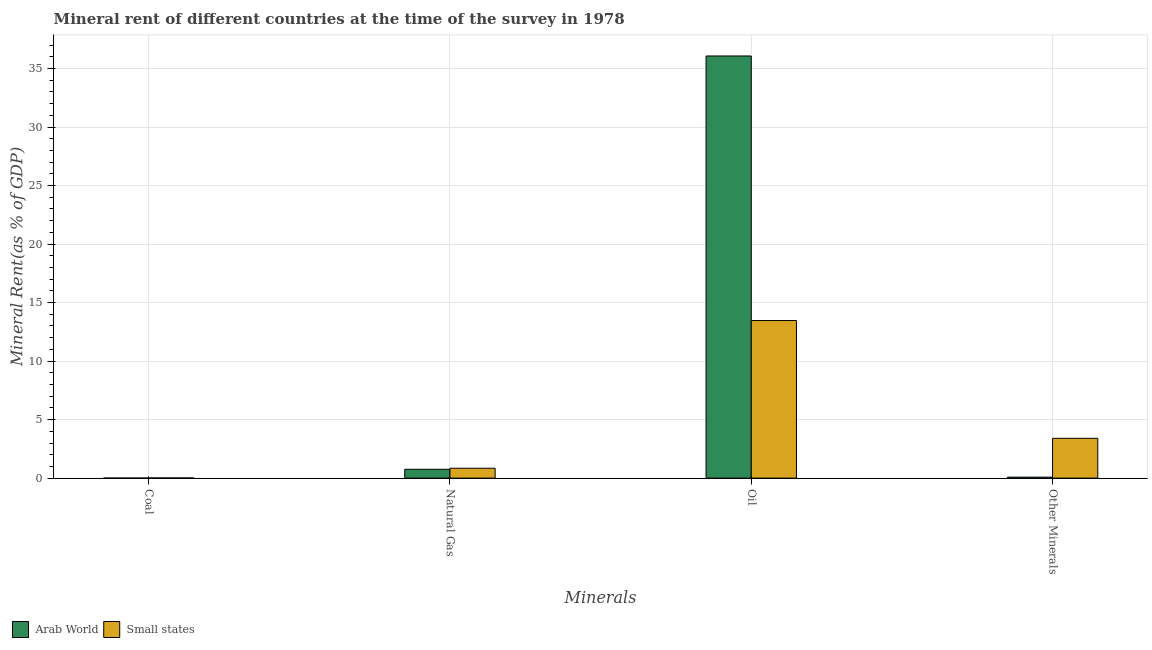How many different coloured bars are there?
Provide a succinct answer. 2. Are the number of bars on each tick of the X-axis equal?
Ensure brevity in your answer.  Yes. How many bars are there on the 4th tick from the left?
Provide a short and direct response. 2. How many bars are there on the 4th tick from the right?
Provide a succinct answer. 2. What is the label of the 3rd group of bars from the left?
Ensure brevity in your answer.  Oil. What is the coal rent in Small states?
Offer a very short reply. 0.01. Across all countries, what is the maximum coal rent?
Keep it short and to the point. 0.01. Across all countries, what is the minimum coal rent?
Provide a succinct answer. 0. In which country was the coal rent maximum?
Provide a short and direct response. Small states. In which country was the oil rent minimum?
Provide a short and direct response. Small states. What is the total coal rent in the graph?
Offer a terse response. 0.02. What is the difference between the  rent of other minerals in Arab World and that in Small states?
Give a very brief answer. -3.32. What is the difference between the natural gas rent in Small states and the coal rent in Arab World?
Offer a terse response. 0.84. What is the average  rent of other minerals per country?
Your response must be concise. 1.74. What is the difference between the coal rent and oil rent in Arab World?
Offer a terse response. -36.07. In how many countries, is the coal rent greater than 1 %?
Ensure brevity in your answer.  0. What is the ratio of the  rent of other minerals in Small states to that in Arab World?
Your response must be concise. 40.73. What is the difference between the highest and the second highest natural gas rent?
Offer a very short reply. 0.09. What is the difference between the highest and the lowest  rent of other minerals?
Keep it short and to the point. 3.32. Is the sum of the natural gas rent in Small states and Arab World greater than the maximum oil rent across all countries?
Offer a very short reply. No. What does the 2nd bar from the left in Other Minerals represents?
Your response must be concise. Small states. What does the 2nd bar from the right in Coal represents?
Your answer should be compact. Arab World. Is it the case that in every country, the sum of the coal rent and natural gas rent is greater than the oil rent?
Offer a terse response. No. Are all the bars in the graph horizontal?
Keep it short and to the point. No. Are the values on the major ticks of Y-axis written in scientific E-notation?
Your response must be concise. No. Does the graph contain grids?
Provide a short and direct response. Yes. Where does the legend appear in the graph?
Your answer should be very brief. Bottom left. How many legend labels are there?
Give a very brief answer. 2. What is the title of the graph?
Offer a very short reply. Mineral rent of different countries at the time of the survey in 1978. Does "Northern Mariana Islands" appear as one of the legend labels in the graph?
Make the answer very short. No. What is the label or title of the X-axis?
Your answer should be very brief. Minerals. What is the label or title of the Y-axis?
Offer a very short reply. Mineral Rent(as % of GDP). What is the Mineral Rent(as % of GDP) in Arab World in Coal?
Your response must be concise. 0. What is the Mineral Rent(as % of GDP) in Small states in Coal?
Make the answer very short. 0.01. What is the Mineral Rent(as % of GDP) of Arab World in Natural Gas?
Your response must be concise. 0.76. What is the Mineral Rent(as % of GDP) in Small states in Natural Gas?
Keep it short and to the point. 0.84. What is the Mineral Rent(as % of GDP) in Arab World in Oil?
Keep it short and to the point. 36.08. What is the Mineral Rent(as % of GDP) of Small states in Oil?
Offer a very short reply. 13.47. What is the Mineral Rent(as % of GDP) in Arab World in Other Minerals?
Your answer should be very brief. 0.08. What is the Mineral Rent(as % of GDP) in Small states in Other Minerals?
Your answer should be compact. 3.4. Across all Minerals, what is the maximum Mineral Rent(as % of GDP) in Arab World?
Your response must be concise. 36.08. Across all Minerals, what is the maximum Mineral Rent(as % of GDP) in Small states?
Offer a very short reply. 13.47. Across all Minerals, what is the minimum Mineral Rent(as % of GDP) of Arab World?
Make the answer very short. 0. Across all Minerals, what is the minimum Mineral Rent(as % of GDP) in Small states?
Give a very brief answer. 0.01. What is the total Mineral Rent(as % of GDP) in Arab World in the graph?
Ensure brevity in your answer.  36.92. What is the total Mineral Rent(as % of GDP) in Small states in the graph?
Keep it short and to the point. 17.73. What is the difference between the Mineral Rent(as % of GDP) in Arab World in Coal and that in Natural Gas?
Offer a very short reply. -0.75. What is the difference between the Mineral Rent(as % of GDP) of Small states in Coal and that in Natural Gas?
Your answer should be compact. -0.83. What is the difference between the Mineral Rent(as % of GDP) of Arab World in Coal and that in Oil?
Provide a succinct answer. -36.07. What is the difference between the Mineral Rent(as % of GDP) of Small states in Coal and that in Oil?
Your answer should be very brief. -13.45. What is the difference between the Mineral Rent(as % of GDP) in Arab World in Coal and that in Other Minerals?
Your response must be concise. -0.08. What is the difference between the Mineral Rent(as % of GDP) in Small states in Coal and that in Other Minerals?
Provide a succinct answer. -3.39. What is the difference between the Mineral Rent(as % of GDP) in Arab World in Natural Gas and that in Oil?
Your answer should be compact. -35.32. What is the difference between the Mineral Rent(as % of GDP) of Small states in Natural Gas and that in Oil?
Make the answer very short. -12.62. What is the difference between the Mineral Rent(as % of GDP) of Arab World in Natural Gas and that in Other Minerals?
Your answer should be very brief. 0.67. What is the difference between the Mineral Rent(as % of GDP) of Small states in Natural Gas and that in Other Minerals?
Offer a very short reply. -2.56. What is the difference between the Mineral Rent(as % of GDP) of Arab World in Oil and that in Other Minerals?
Ensure brevity in your answer.  35.99. What is the difference between the Mineral Rent(as % of GDP) of Small states in Oil and that in Other Minerals?
Give a very brief answer. 10.07. What is the difference between the Mineral Rent(as % of GDP) of Arab World in Coal and the Mineral Rent(as % of GDP) of Small states in Natural Gas?
Give a very brief answer. -0.84. What is the difference between the Mineral Rent(as % of GDP) of Arab World in Coal and the Mineral Rent(as % of GDP) of Small states in Oil?
Make the answer very short. -13.47. What is the difference between the Mineral Rent(as % of GDP) in Arab World in Coal and the Mineral Rent(as % of GDP) in Small states in Other Minerals?
Your answer should be compact. -3.4. What is the difference between the Mineral Rent(as % of GDP) of Arab World in Natural Gas and the Mineral Rent(as % of GDP) of Small states in Oil?
Provide a short and direct response. -12.71. What is the difference between the Mineral Rent(as % of GDP) of Arab World in Natural Gas and the Mineral Rent(as % of GDP) of Small states in Other Minerals?
Provide a succinct answer. -2.65. What is the difference between the Mineral Rent(as % of GDP) in Arab World in Oil and the Mineral Rent(as % of GDP) in Small states in Other Minerals?
Your answer should be compact. 32.67. What is the average Mineral Rent(as % of GDP) in Arab World per Minerals?
Provide a short and direct response. 9.23. What is the average Mineral Rent(as % of GDP) of Small states per Minerals?
Give a very brief answer. 4.43. What is the difference between the Mineral Rent(as % of GDP) of Arab World and Mineral Rent(as % of GDP) of Small states in Coal?
Offer a very short reply. -0.01. What is the difference between the Mineral Rent(as % of GDP) of Arab World and Mineral Rent(as % of GDP) of Small states in Natural Gas?
Offer a terse response. -0.09. What is the difference between the Mineral Rent(as % of GDP) of Arab World and Mineral Rent(as % of GDP) of Small states in Oil?
Your answer should be compact. 22.61. What is the difference between the Mineral Rent(as % of GDP) in Arab World and Mineral Rent(as % of GDP) in Small states in Other Minerals?
Offer a very short reply. -3.32. What is the ratio of the Mineral Rent(as % of GDP) of Arab World in Coal to that in Natural Gas?
Your answer should be very brief. 0. What is the ratio of the Mineral Rent(as % of GDP) of Small states in Coal to that in Natural Gas?
Offer a very short reply. 0.02. What is the ratio of the Mineral Rent(as % of GDP) in Arab World in Coal to that in Other Minerals?
Make the answer very short. 0.02. What is the ratio of the Mineral Rent(as % of GDP) of Small states in Coal to that in Other Minerals?
Your answer should be very brief. 0. What is the ratio of the Mineral Rent(as % of GDP) of Arab World in Natural Gas to that in Oil?
Give a very brief answer. 0.02. What is the ratio of the Mineral Rent(as % of GDP) in Small states in Natural Gas to that in Oil?
Your answer should be compact. 0.06. What is the ratio of the Mineral Rent(as % of GDP) in Arab World in Natural Gas to that in Other Minerals?
Your response must be concise. 9.05. What is the ratio of the Mineral Rent(as % of GDP) in Small states in Natural Gas to that in Other Minerals?
Your answer should be very brief. 0.25. What is the ratio of the Mineral Rent(as % of GDP) in Arab World in Oil to that in Other Minerals?
Your answer should be compact. 432. What is the ratio of the Mineral Rent(as % of GDP) in Small states in Oil to that in Other Minerals?
Your answer should be very brief. 3.96. What is the difference between the highest and the second highest Mineral Rent(as % of GDP) of Arab World?
Offer a very short reply. 35.32. What is the difference between the highest and the second highest Mineral Rent(as % of GDP) of Small states?
Your answer should be compact. 10.07. What is the difference between the highest and the lowest Mineral Rent(as % of GDP) of Arab World?
Offer a very short reply. 36.07. What is the difference between the highest and the lowest Mineral Rent(as % of GDP) in Small states?
Keep it short and to the point. 13.45. 